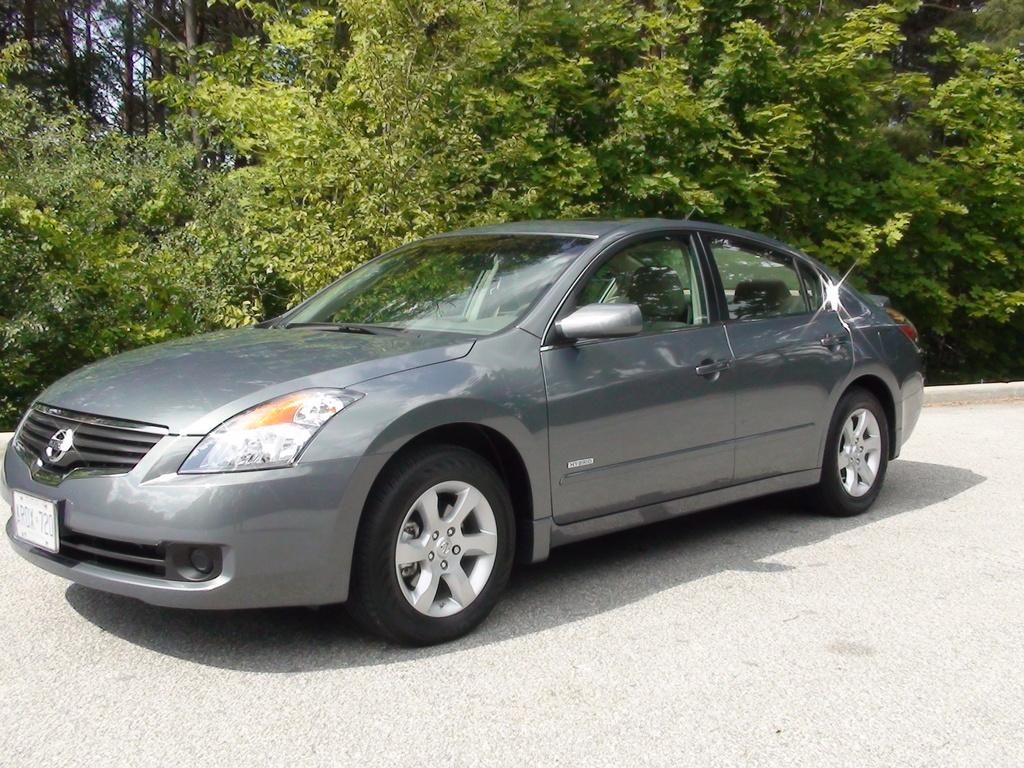What type of vehicle is shown?
Offer a very short reply. Nissan. 